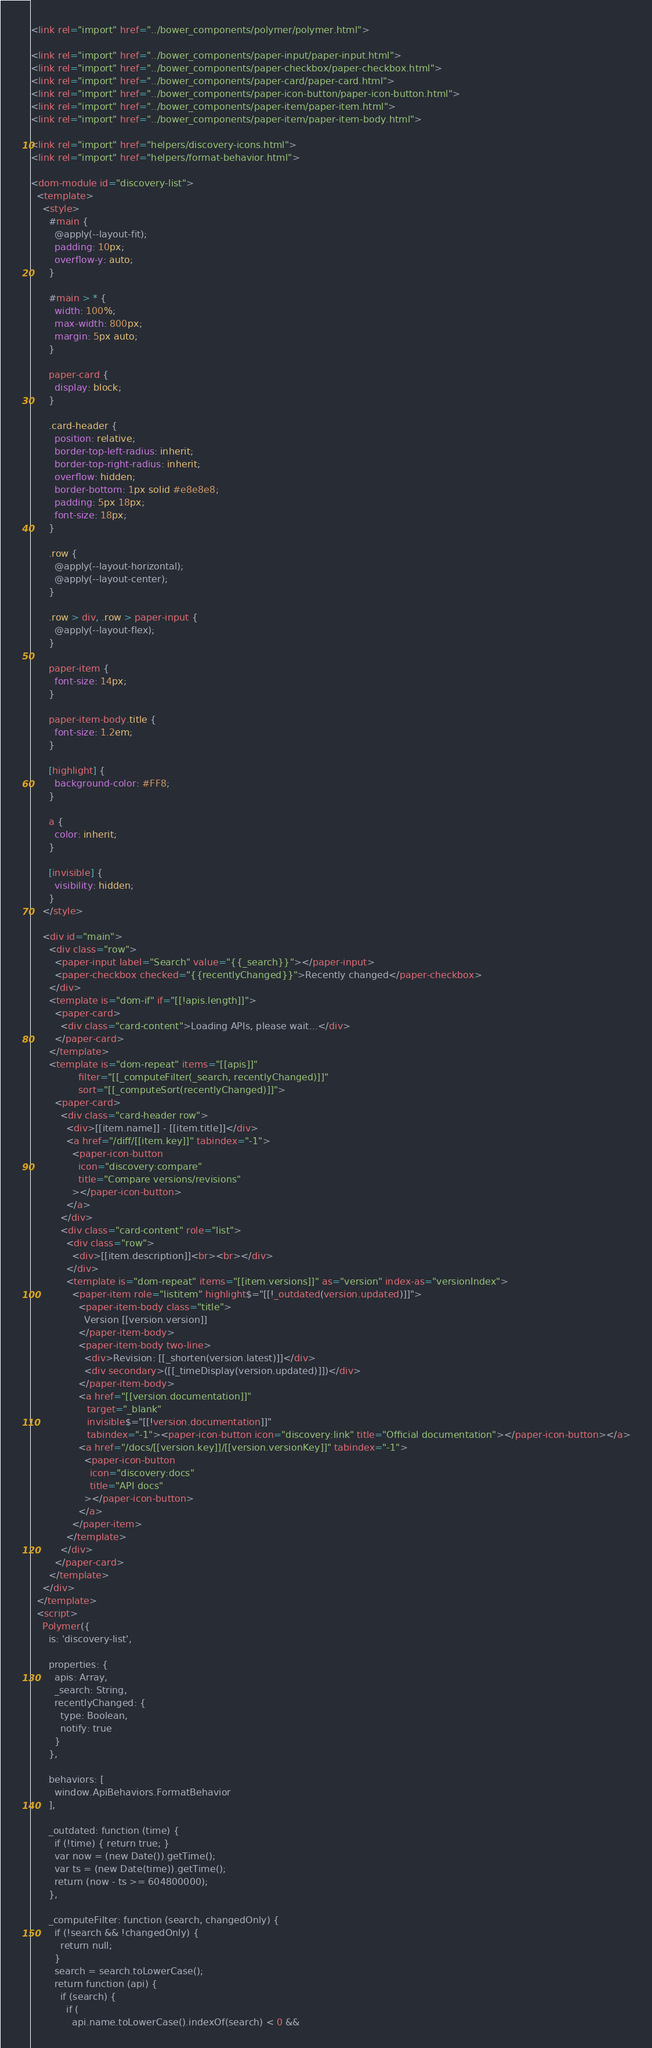<code> <loc_0><loc_0><loc_500><loc_500><_HTML_><link rel="import" href="../bower_components/polymer/polymer.html">

<link rel="import" href="../bower_components/paper-input/paper-input.html">
<link rel="import" href="../bower_components/paper-checkbox/paper-checkbox.html">
<link rel="import" href="../bower_components/paper-card/paper-card.html">
<link rel="import" href="../bower_components/paper-icon-button/paper-icon-button.html">
<link rel="import" href="../bower_components/paper-item/paper-item.html">
<link rel="import" href="../bower_components/paper-item/paper-item-body.html">

<link rel="import" href="helpers/discovery-icons.html">
<link rel="import" href="helpers/format-behavior.html">

<dom-module id="discovery-list">
  <template>
    <style>
      #main {
        @apply(--layout-fit);
        padding: 10px;
        overflow-y: auto;
      }

      #main > * {
        width: 100%;
        max-width: 800px;
        margin: 5px auto;
      }

      paper-card {
        display: block;
      }

      .card-header {
        position: relative;
        border-top-left-radius: inherit;
        border-top-right-radius: inherit;
        overflow: hidden;
        border-bottom: 1px solid #e8e8e8;
        padding: 5px 18px;
        font-size: 18px;
      }

      .row {
        @apply(--layout-horizontal);
        @apply(--layout-center);
      }

      .row > div, .row > paper-input {
        @apply(--layout-flex);
      }

      paper-item {
        font-size: 14px;
      }

      paper-item-body.title {
        font-size: 1.2em;
      }

      [highlight] {
        background-color: #FF8;
      }

      a {
        color: inherit;
      }

      [invisible] {
        visibility: hidden;
      }
    </style>

    <div id="main">
      <div class="row">
        <paper-input label="Search" value="{{_search}}"></paper-input>
        <paper-checkbox checked="{{recentlyChanged}}">Recently changed</paper-checkbox>
      </div>
      <template is="dom-if" if="[[!apis.length]]">
        <paper-card>
          <div class="card-content">Loading APIs, please wait...</div>
        </paper-card>
      </template>
      <template is="dom-repeat" items="[[apis]]"
                filter="[[_computeFilter(_search, recentlyChanged)]]"
                sort="[[_computeSort(recentlyChanged)]]">
        <paper-card>
          <div class="card-header row">
            <div>[[item.name]] - [[item.title]]</div>
            <a href="/diff/[[item.key]]" tabindex="-1">
              <paper-icon-button
                icon="discovery:compare"
                title="Compare versions/revisions"
              ></paper-icon-button>
            </a>
          </div>
          <div class="card-content" role="list">
            <div class="row">
              <div>[[item.description]]<br><br></div>
            </div>
            <template is="dom-repeat" items="[[item.versions]]" as="version" index-as="versionIndex">
              <paper-item role="listitem" highlight$="[[!_outdated(version.updated)]]">
                <paper-item-body class="title">
                  Version [[version.version]]
                </paper-item-body>
                <paper-item-body two-line>
                  <div>Revision: [[_shorten(version.latest)]]</div>
                  <div secondary>([[_timeDisplay(version.updated)]])</div>
                </paper-item-body>
                <a href="[[version.documentation]]"
                   target="_blank"
                   invisible$="[[!version.documentation]]"
                   tabindex="-1"><paper-icon-button icon="discovery:link" title="Official documentation"></paper-icon-button></a>
                <a href="/docs/[[version.key]]/[[version.versionKey]]" tabindex="-1">
                  <paper-icon-button
                    icon="discovery:docs"
                    title="API docs"
                  ></paper-icon-button>
                </a>
              </paper-item>
            </template>
          </div>
        </paper-card>
      </template>
    </div>
  </template>
  <script>
    Polymer({
      is: 'discovery-list',

      properties: {
        apis: Array,
        _search: String,
        recentlyChanged: {
          type: Boolean,
          notify: true
        }
      },

      behaviors: [
        window.ApiBehaviors.FormatBehavior
      ],

      _outdated: function (time) {
        if (!time) { return true; }
        var now = (new Date()).getTime();
        var ts = (new Date(time)).getTime();
        return (now - ts >= 604800000);
      },

      _computeFilter: function (search, changedOnly) {
        if (!search && !changedOnly) {
          return null;
        }
        search = search.toLowerCase();
        return function (api) {
          if (search) {
            if (
              api.name.toLowerCase().indexOf(search) < 0 &&</code> 